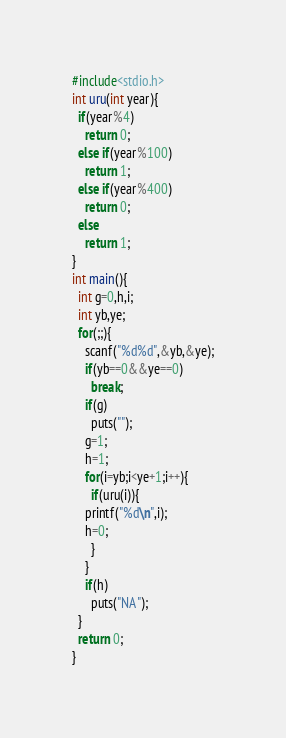<code> <loc_0><loc_0><loc_500><loc_500><_C_>#include<stdio.h>
int uru(int year){
  if(year%4)
    return 0;
  else if(year%100)
    return 1;
  else if(year%400)
    return 0;
  else
    return 1;
}
int main(){
  int g=0,h,i;
  int yb,ye;
  for(;;){
    scanf("%d%d",&yb,&ye);
    if(yb==0&&ye==0)
      break;
    if(g)
      puts("");
    g=1;
    h=1;
    for(i=yb;i<ye+1;i++){
      if(uru(i)){
	printf("%d\n",i);
	h=0;
      }
    }
    if(h)
      puts("NA");
  }
  return 0;
}</code> 